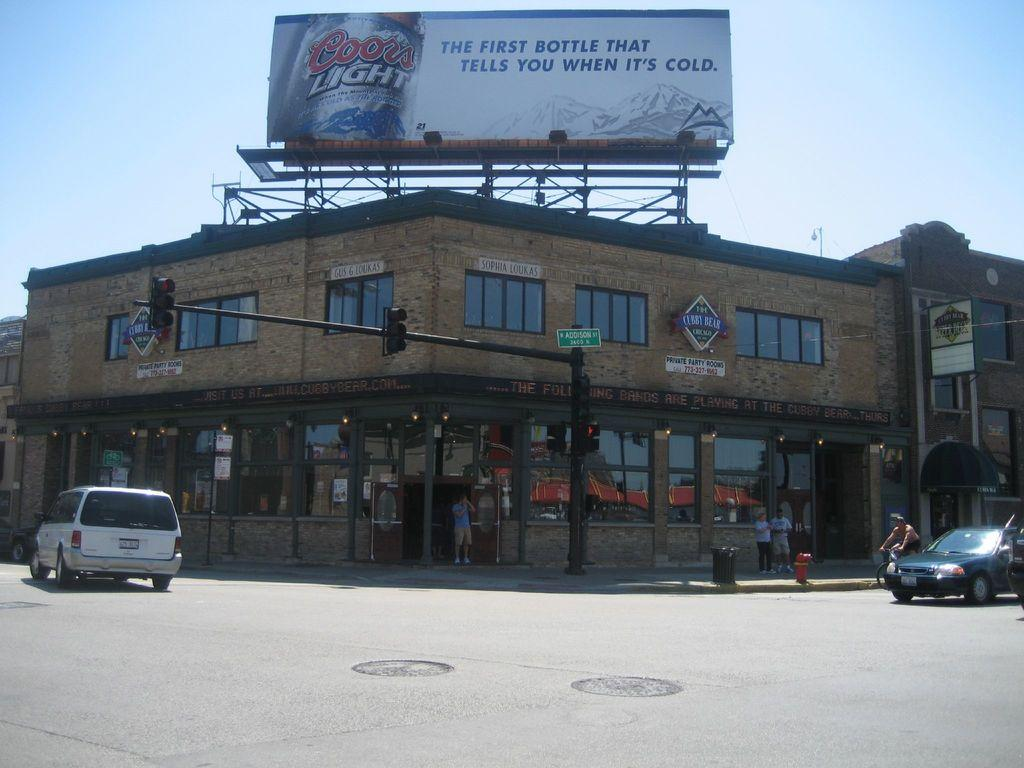<image>
Write a terse but informative summary of the picture. a building with a Coors Light billboard above it 